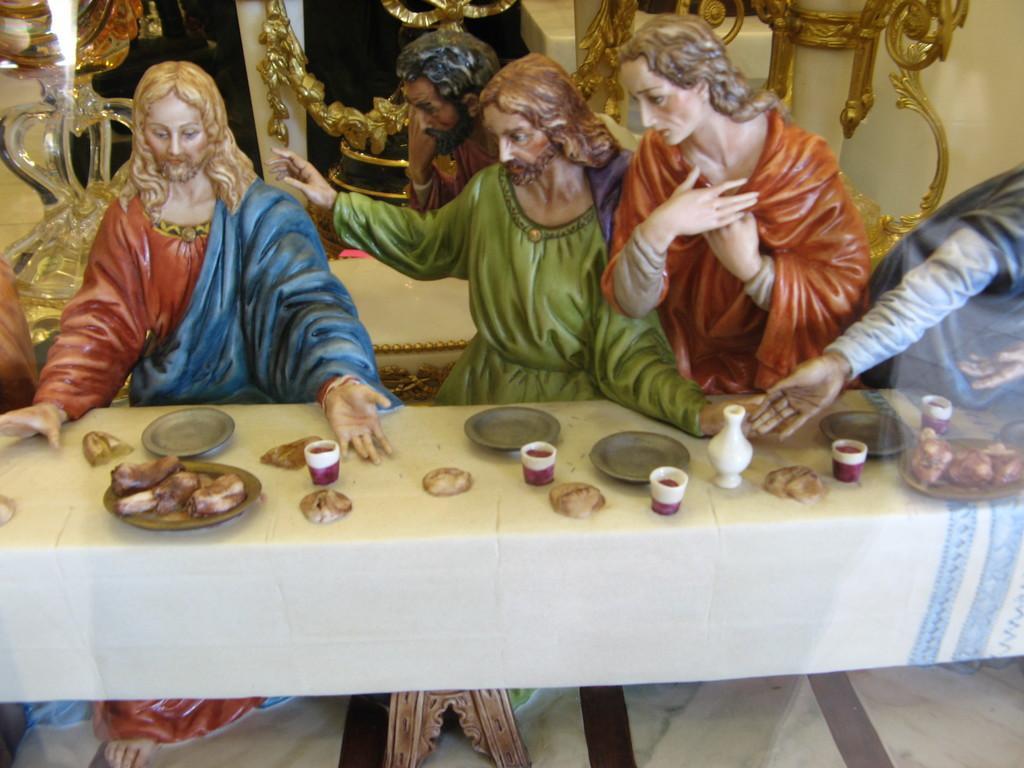Please provide a concise description of this image. In this image we can see few statues of persons. Behind the statues we can see few objects. In the foreground we can see a group of objects on a table. 